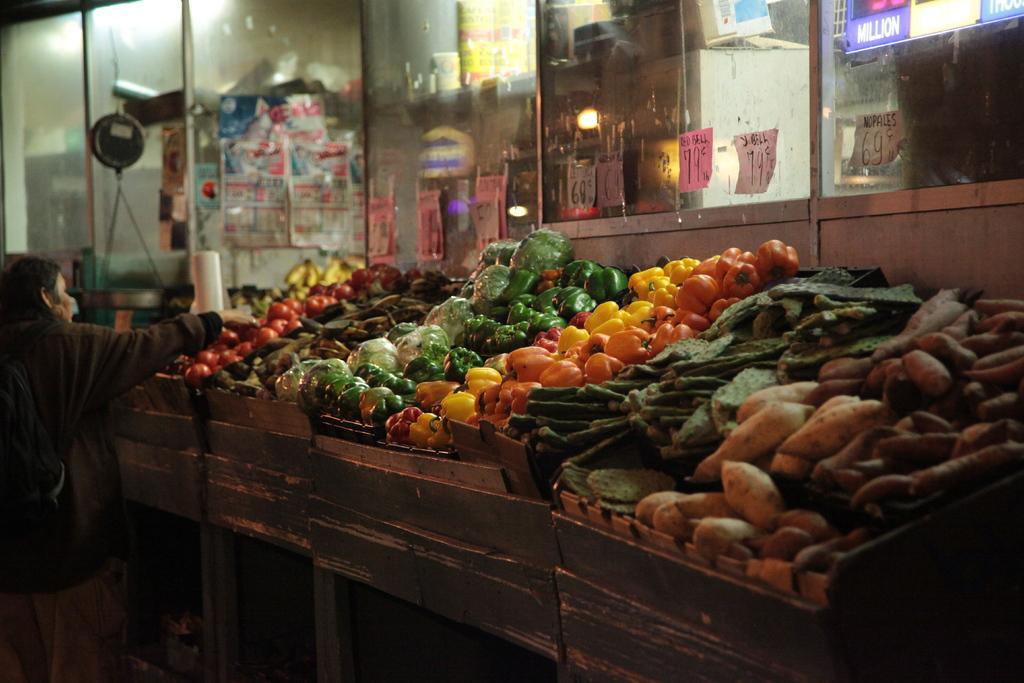Describe this image in one or two sentences. In the image we can see there are different varieties of vegetables kept in the container. This is a glass window, light, paper and there is a person standing, wearing clothes. 